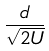Convert formula to latex. <formula><loc_0><loc_0><loc_500><loc_500>\frac { d } { \sqrt { 2 U } }</formula> 